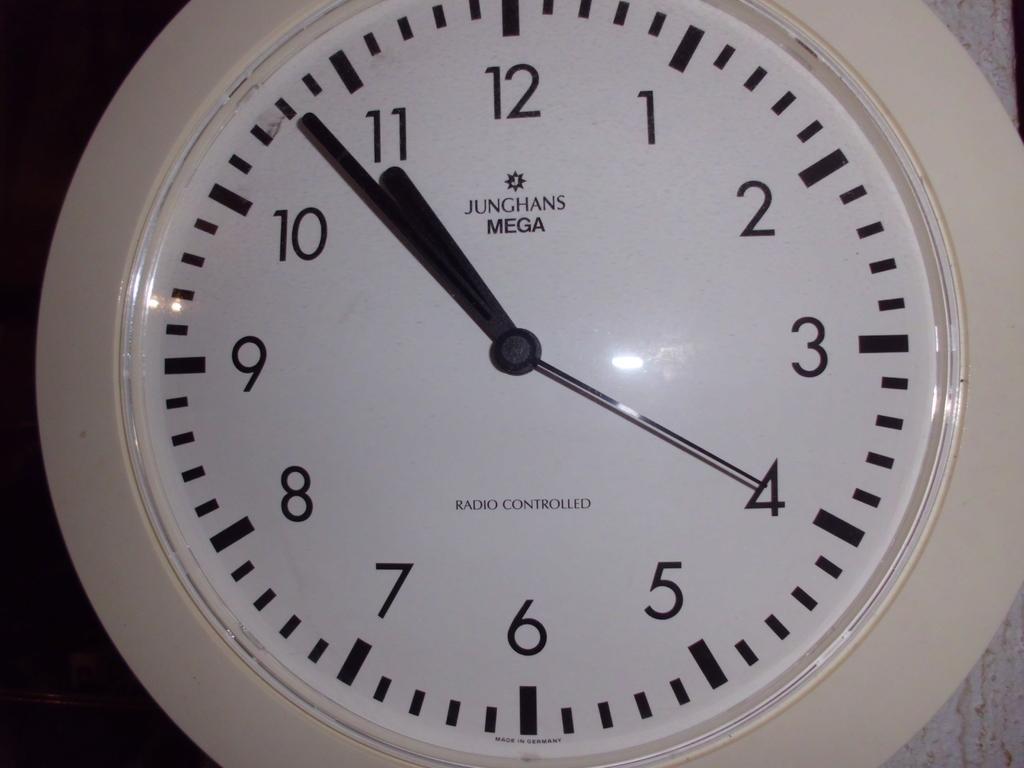<image>
Describe the image concisely. the numbers 1 to 12 on the front of a clock 